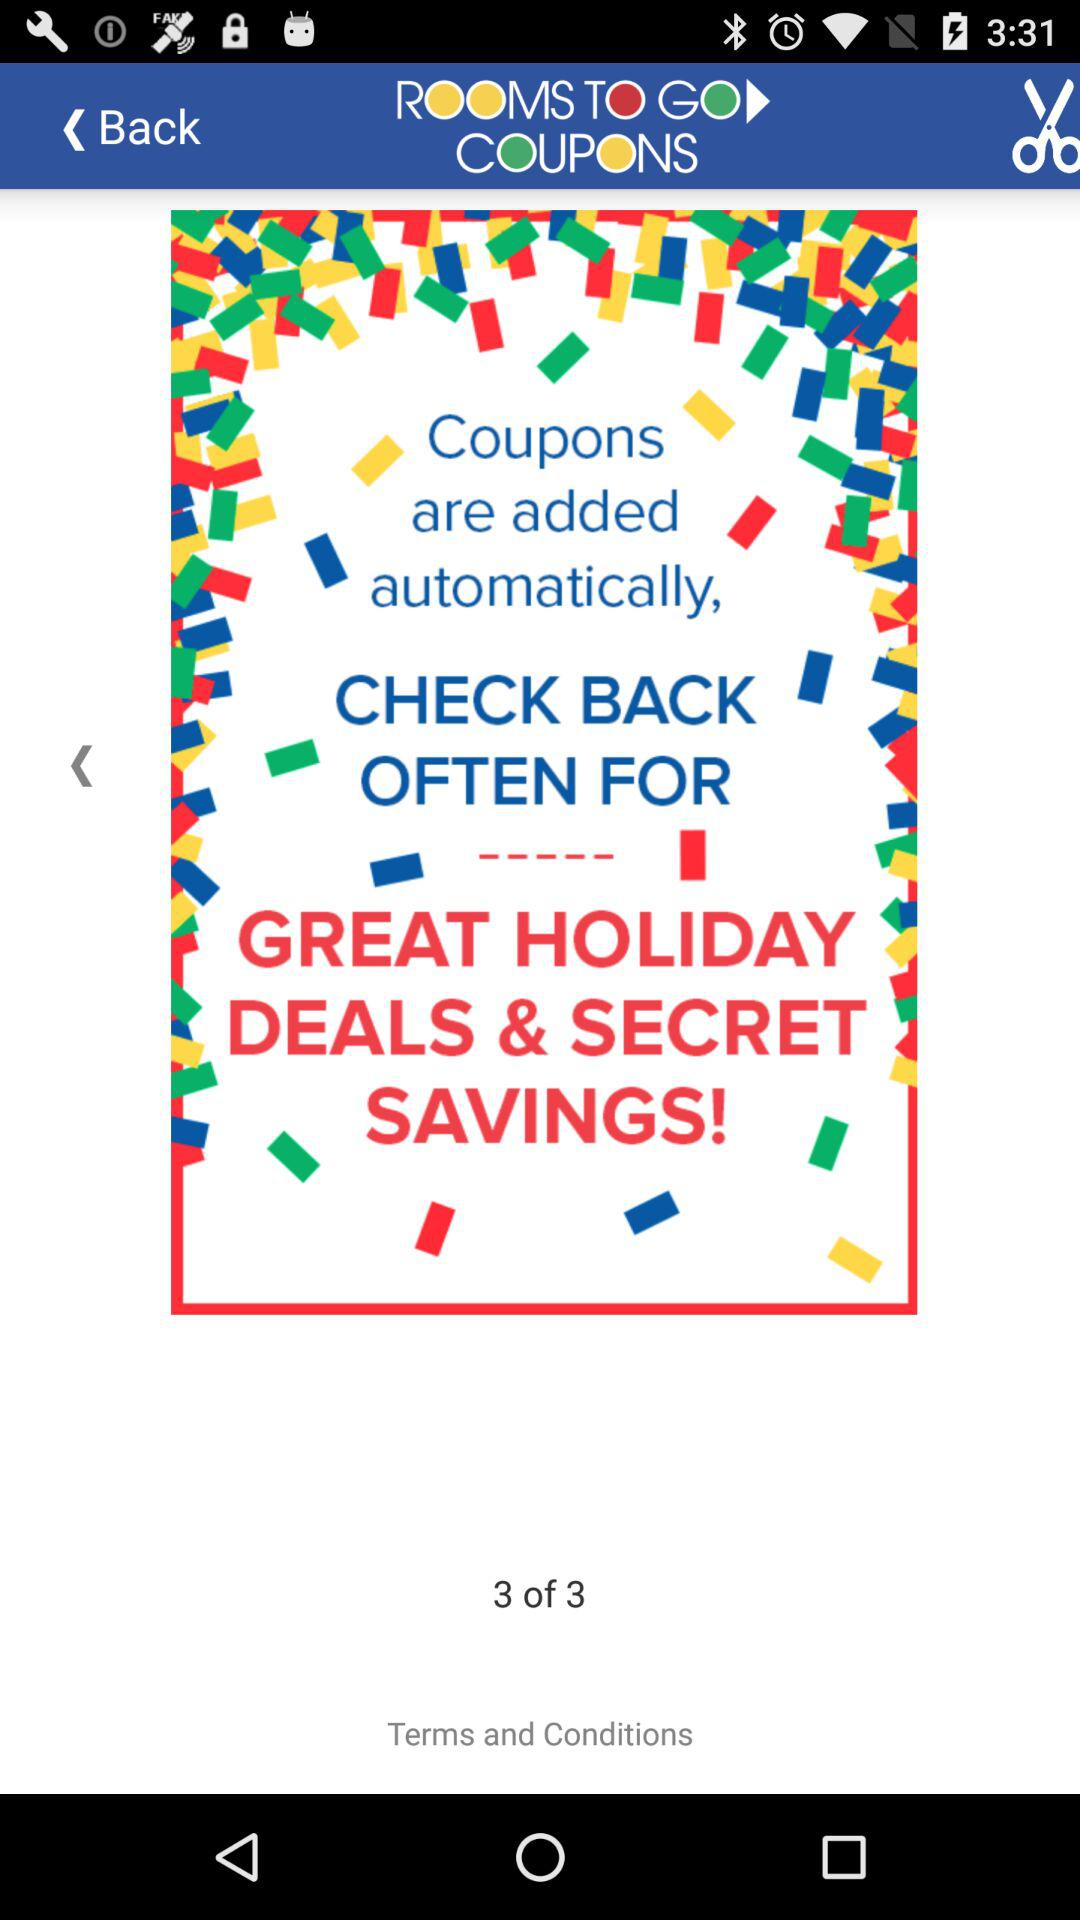At what page am I at? You are on page number 3. 